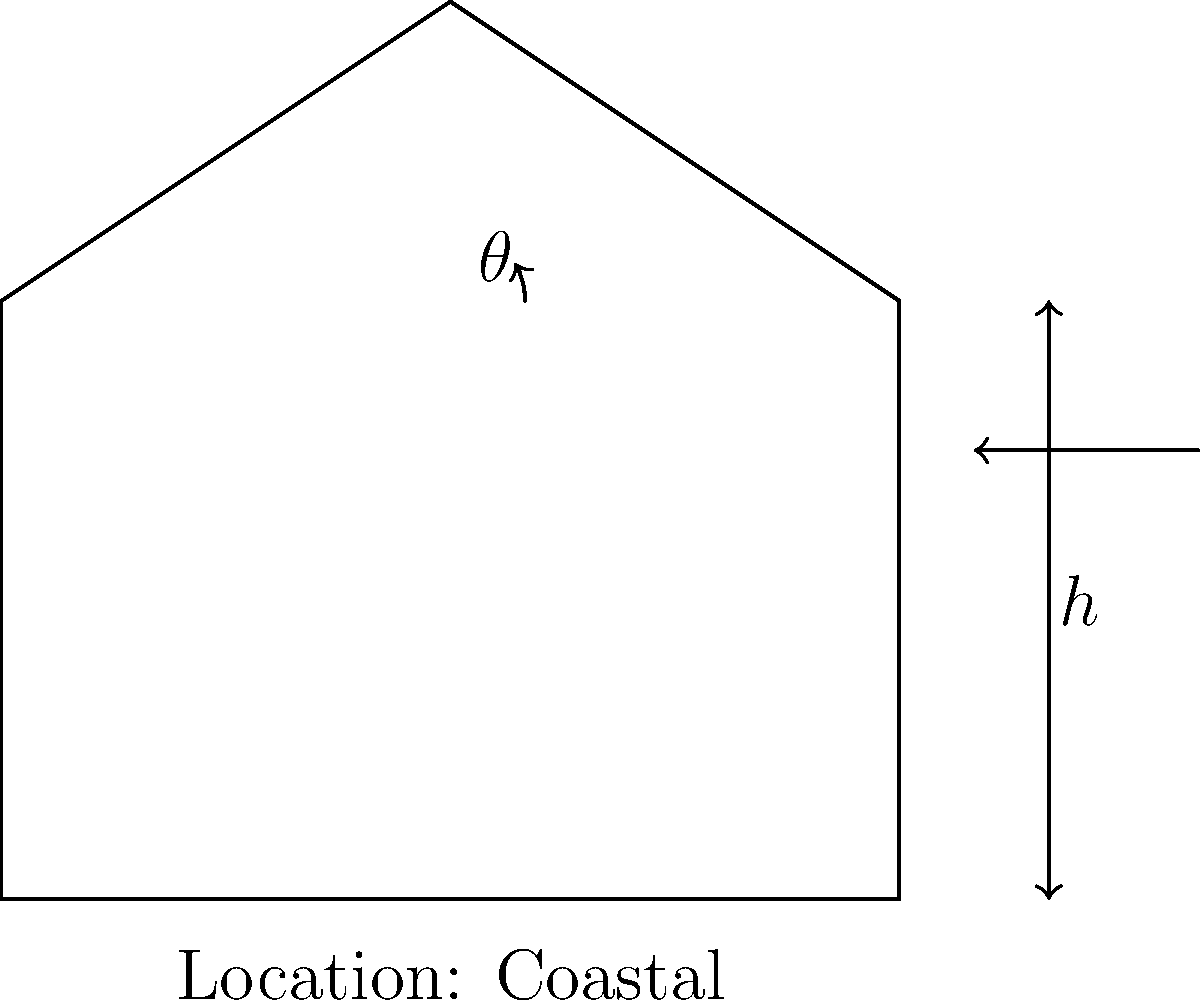As a literary agent representing an author of mathematical thrillers, you're reviewing a manuscript that involves a civil engineering problem. The protagonist needs to determine the optimal angle $\theta$ for a roof to withstand wind forces on a coastal building with height $h$. Given that the wind force $F$ is proportional to $\sin(\theta)$ and inversely proportional to the square root of $h$, what would be the general form of the equation to calculate the optimal angle $\theta$? To solve this problem, we need to follow these steps:

1. Understand the relationships:
   - Wind force $F$ is proportional to $\sin(\theta)$
   - Wind force $F$ is inversely proportional to $\sqrt{h}$

2. Express these relationships mathematically:
   $F \propto \frac{\sin(\theta)}{\sqrt{h}}$

3. Introduce a constant $k$ to convert the proportionality to an equation:
   $F = k \cdot \frac{\sin(\theta)}{\sqrt{h}}$

4. To find the optimal angle, we need to maximize the wind resistance, which is inversely related to the wind force. So, we want to minimize $F$.

5. The minimum value of $F$ occurs when $\frac{d}{d\theta}(F) = 0$

6. Differentiate $F$ with respect to $\theta$:
   $\frac{d}{d\theta}(F) = k \cdot \frac{\cos(\theta)}{\sqrt{h}}$

7. Set this equal to zero:
   $k \cdot \frac{\cos(\theta)}{\sqrt{h}} = 0$

8. Solve for $\theta$:
   $\cos(\theta) = 0$
   $\theta = \arccos(0) = 90°$

9. The optimal angle is 90°, regardless of the height or location. However, this is not practical for a roof.

10. In reality, the optimal angle would be a balance between wind resistance and other factors like rain runoff, snow load, and structural integrity.

11. A more practical equation might include these factors, resulting in a form like:
    $\theta_{optimal} = f(h, \text{location factors}) = a \cdot \arctan(\frac{b}{\sqrt{h}}) + c$

    Where $a$, $b$, and $c$ are constants determined by location factors and engineering constraints.
Answer: $\theta_{optimal} = f(h, \text{location factors}) = a \cdot \arctan(\frac{b}{\sqrt{h}}) + c$ 